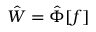<formula> <loc_0><loc_0><loc_500><loc_500>\hat { W } = \hat { \Phi } [ f ]</formula> 